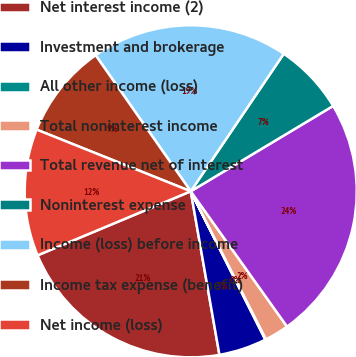Convert chart. <chart><loc_0><loc_0><loc_500><loc_500><pie_chart><fcel>Net interest income (2)<fcel>Investment and brokerage<fcel>All other income (loss)<fcel>Total noninterest income<fcel>Total revenue net of interest<fcel>Noninterest expense<fcel>Income (loss) before income<fcel>Income tax expense (benefit)<fcel>Net income (loss)<nl><fcel>21.46%<fcel>4.65%<fcel>0.07%<fcel>2.36%<fcel>23.75%<fcel>6.94%<fcel>19.17%<fcel>9.23%<fcel>12.36%<nl></chart> 